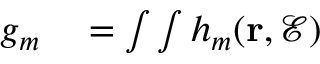<formula> <loc_0><loc_0><loc_500><loc_500>\begin{array} { r l } { g _ { m } } & = \int \int h _ { m } ( r , \mathcal { E } ) } \end{array}</formula> 